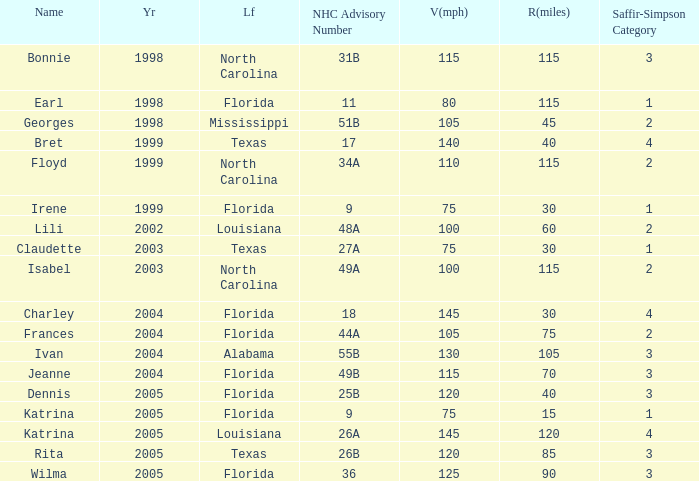What was the highest SaffirSimpson with an NHC advisory of 18? 4.0. 